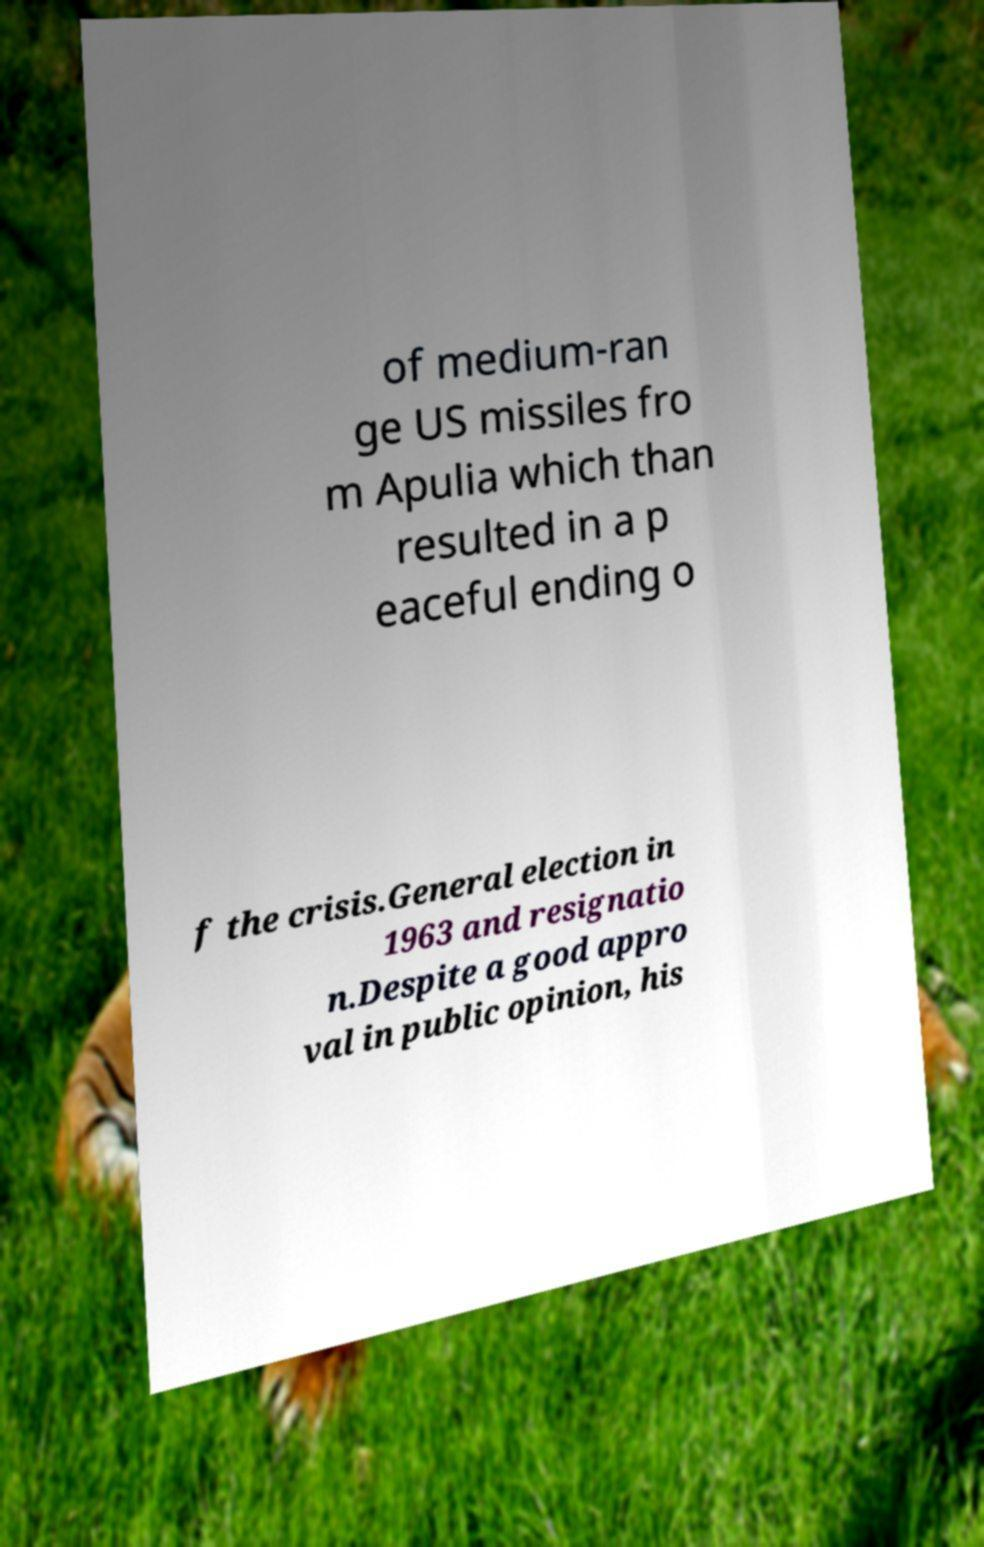I need the written content from this picture converted into text. Can you do that? of medium-ran ge US missiles fro m Apulia which than resulted in a p eaceful ending o f the crisis.General election in 1963 and resignatio n.Despite a good appro val in public opinion, his 